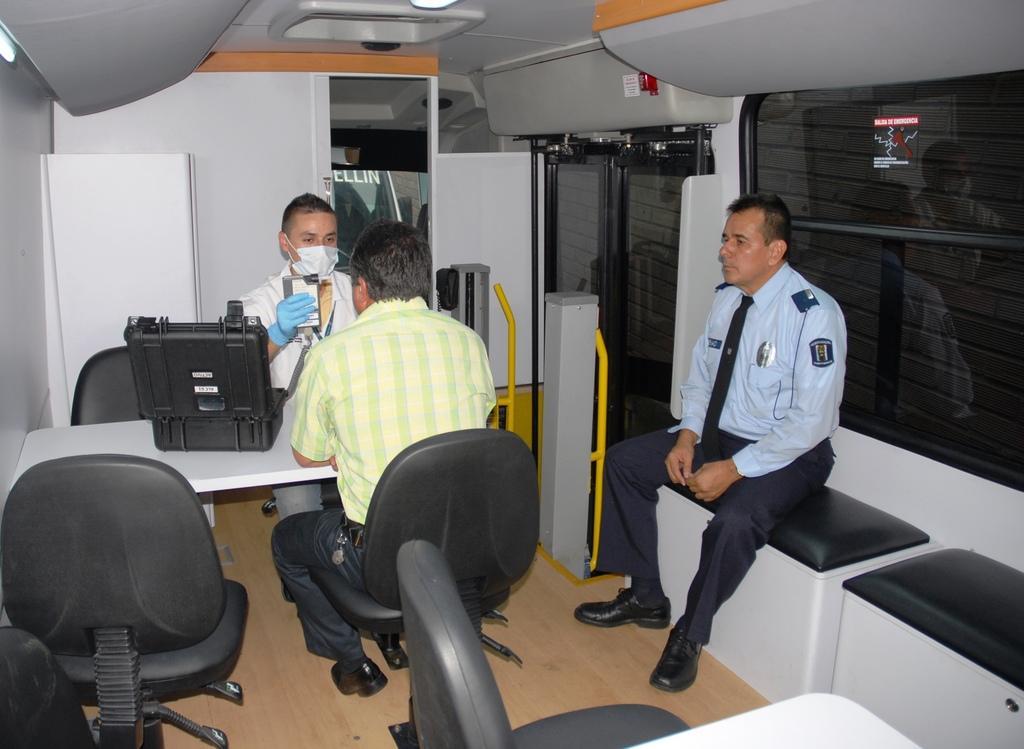How would you summarize this image in a sentence or two? In this image I see 3 men and all of them are sitting and there is a suitcase on this table and there are few chairs, I can also see there is a door and a window over here. 